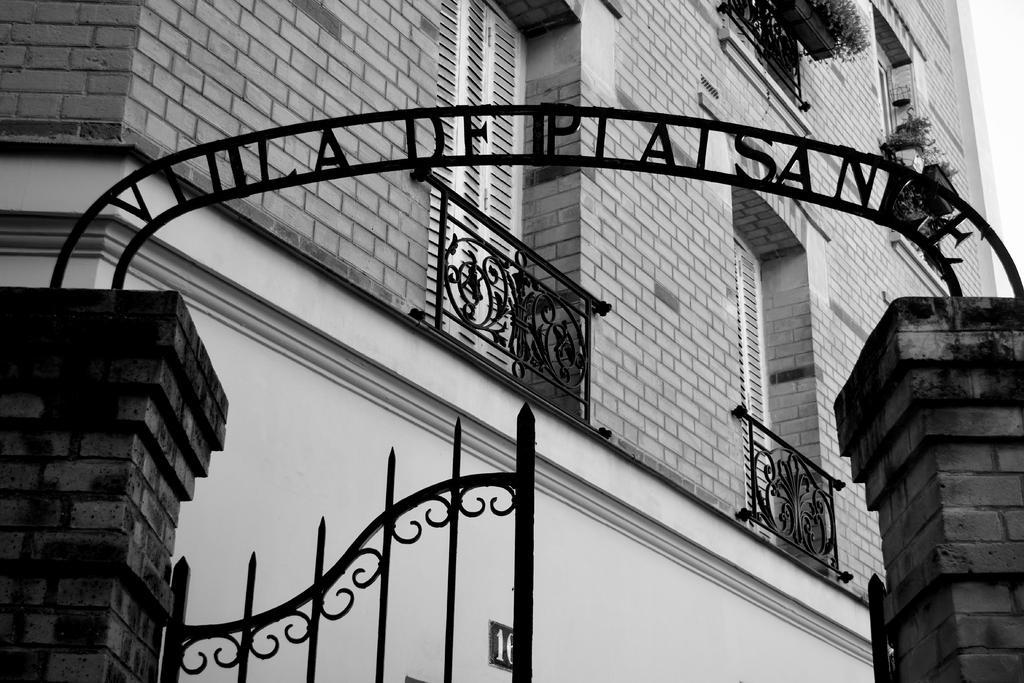How would you summarize this image in a sentence or two? It's an entrance, there is a building in the middle of this image. 